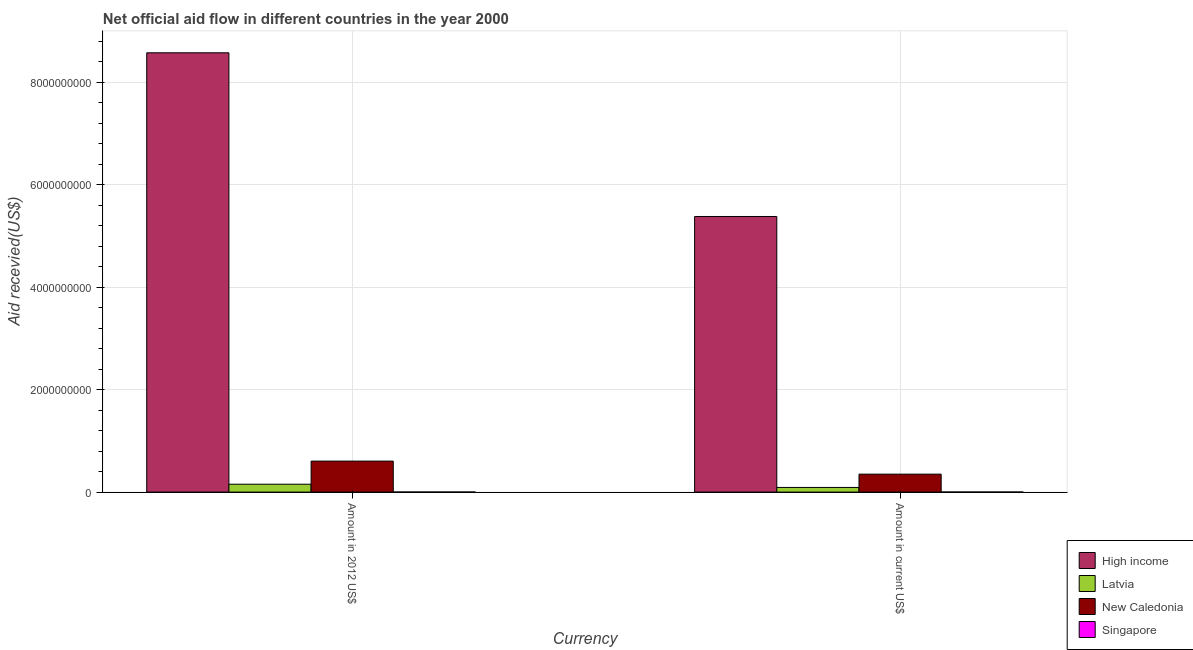How many different coloured bars are there?
Ensure brevity in your answer.  4. How many groups of bars are there?
Your answer should be very brief. 2. Are the number of bars per tick equal to the number of legend labels?
Provide a succinct answer. Yes. How many bars are there on the 1st tick from the left?
Your answer should be compact. 4. What is the label of the 2nd group of bars from the left?
Your answer should be very brief. Amount in current US$. What is the amount of aid received(expressed in us$) in High income?
Provide a short and direct response. 5.38e+09. Across all countries, what is the maximum amount of aid received(expressed in us$)?
Your response must be concise. 5.38e+09. Across all countries, what is the minimum amount of aid received(expressed in 2012 us$)?
Your answer should be very brief. 9.80e+05. In which country was the amount of aid received(expressed in us$) minimum?
Ensure brevity in your answer.  Singapore. What is the total amount of aid received(expressed in us$) in the graph?
Provide a short and direct response. 5.82e+09. What is the difference between the amount of aid received(expressed in us$) in New Caledonia and that in Singapore?
Your response must be concise. 3.49e+08. What is the difference between the amount of aid received(expressed in us$) in New Caledonia and the amount of aid received(expressed in 2012 us$) in High income?
Your response must be concise. -8.22e+09. What is the average amount of aid received(expressed in us$) per country?
Offer a very short reply. 1.46e+09. What is the difference between the amount of aid received(expressed in us$) and amount of aid received(expressed in 2012 us$) in Singapore?
Offer a terse response. 1.10e+05. What is the ratio of the amount of aid received(expressed in us$) in Singapore to that in New Caledonia?
Offer a very short reply. 0. Is the amount of aid received(expressed in 2012 us$) in New Caledonia less than that in Latvia?
Your response must be concise. No. What does the 4th bar from the left in Amount in current US$ represents?
Keep it short and to the point. Singapore. What does the 3rd bar from the right in Amount in 2012 US$ represents?
Provide a short and direct response. Latvia. How many bars are there?
Make the answer very short. 8. What is the difference between two consecutive major ticks on the Y-axis?
Your response must be concise. 2.00e+09. Does the graph contain grids?
Ensure brevity in your answer.  Yes. Where does the legend appear in the graph?
Make the answer very short. Bottom right. How many legend labels are there?
Offer a very short reply. 4. How are the legend labels stacked?
Make the answer very short. Vertical. What is the title of the graph?
Make the answer very short. Net official aid flow in different countries in the year 2000. What is the label or title of the X-axis?
Offer a very short reply. Currency. What is the label or title of the Y-axis?
Keep it short and to the point. Aid recevied(US$). What is the Aid recevied(US$) of High income in Amount in 2012 US$?
Provide a short and direct response. 8.57e+09. What is the Aid recevied(US$) of Latvia in Amount in 2012 US$?
Offer a very short reply. 1.54e+08. What is the Aid recevied(US$) in New Caledonia in Amount in 2012 US$?
Your answer should be compact. 6.05e+08. What is the Aid recevied(US$) in Singapore in Amount in 2012 US$?
Make the answer very short. 9.80e+05. What is the Aid recevied(US$) of High income in Amount in current US$?
Your answer should be very brief. 5.38e+09. What is the Aid recevied(US$) in Latvia in Amount in current US$?
Ensure brevity in your answer.  9.06e+07. What is the Aid recevied(US$) in New Caledonia in Amount in current US$?
Your response must be concise. 3.50e+08. What is the Aid recevied(US$) in Singapore in Amount in current US$?
Offer a very short reply. 1.09e+06. Across all Currency, what is the maximum Aid recevied(US$) of High income?
Offer a terse response. 8.57e+09. Across all Currency, what is the maximum Aid recevied(US$) of Latvia?
Ensure brevity in your answer.  1.54e+08. Across all Currency, what is the maximum Aid recevied(US$) in New Caledonia?
Your answer should be very brief. 6.05e+08. Across all Currency, what is the maximum Aid recevied(US$) in Singapore?
Your answer should be very brief. 1.09e+06. Across all Currency, what is the minimum Aid recevied(US$) in High income?
Offer a very short reply. 5.38e+09. Across all Currency, what is the minimum Aid recevied(US$) in Latvia?
Offer a very short reply. 9.06e+07. Across all Currency, what is the minimum Aid recevied(US$) of New Caledonia?
Offer a terse response. 3.50e+08. Across all Currency, what is the minimum Aid recevied(US$) in Singapore?
Offer a terse response. 9.80e+05. What is the total Aid recevied(US$) of High income in the graph?
Provide a succinct answer. 1.40e+1. What is the total Aid recevied(US$) in Latvia in the graph?
Offer a terse response. 2.44e+08. What is the total Aid recevied(US$) of New Caledonia in the graph?
Your answer should be very brief. 9.55e+08. What is the total Aid recevied(US$) in Singapore in the graph?
Provide a succinct answer. 2.07e+06. What is the difference between the Aid recevied(US$) of High income in Amount in 2012 US$ and that in Amount in current US$?
Ensure brevity in your answer.  3.19e+09. What is the difference between the Aid recevied(US$) of Latvia in Amount in 2012 US$ and that in Amount in current US$?
Your response must be concise. 6.32e+07. What is the difference between the Aid recevied(US$) in New Caledonia in Amount in 2012 US$ and that in Amount in current US$?
Your answer should be very brief. 2.55e+08. What is the difference between the Aid recevied(US$) of Singapore in Amount in 2012 US$ and that in Amount in current US$?
Offer a very short reply. -1.10e+05. What is the difference between the Aid recevied(US$) in High income in Amount in 2012 US$ and the Aid recevied(US$) in Latvia in Amount in current US$?
Give a very brief answer. 8.48e+09. What is the difference between the Aid recevied(US$) in High income in Amount in 2012 US$ and the Aid recevied(US$) in New Caledonia in Amount in current US$?
Your answer should be very brief. 8.22e+09. What is the difference between the Aid recevied(US$) in High income in Amount in 2012 US$ and the Aid recevied(US$) in Singapore in Amount in current US$?
Offer a very short reply. 8.57e+09. What is the difference between the Aid recevied(US$) in Latvia in Amount in 2012 US$ and the Aid recevied(US$) in New Caledonia in Amount in current US$?
Ensure brevity in your answer.  -1.96e+08. What is the difference between the Aid recevied(US$) of Latvia in Amount in 2012 US$ and the Aid recevied(US$) of Singapore in Amount in current US$?
Provide a short and direct response. 1.53e+08. What is the difference between the Aid recevied(US$) of New Caledonia in Amount in 2012 US$ and the Aid recevied(US$) of Singapore in Amount in current US$?
Offer a very short reply. 6.04e+08. What is the average Aid recevied(US$) of High income per Currency?
Provide a short and direct response. 6.98e+09. What is the average Aid recevied(US$) of Latvia per Currency?
Make the answer very short. 1.22e+08. What is the average Aid recevied(US$) in New Caledonia per Currency?
Provide a short and direct response. 4.77e+08. What is the average Aid recevied(US$) of Singapore per Currency?
Your response must be concise. 1.04e+06. What is the difference between the Aid recevied(US$) in High income and Aid recevied(US$) in Latvia in Amount in 2012 US$?
Your answer should be very brief. 8.42e+09. What is the difference between the Aid recevied(US$) in High income and Aid recevied(US$) in New Caledonia in Amount in 2012 US$?
Your answer should be compact. 7.97e+09. What is the difference between the Aid recevied(US$) in High income and Aid recevied(US$) in Singapore in Amount in 2012 US$?
Keep it short and to the point. 8.57e+09. What is the difference between the Aid recevied(US$) of Latvia and Aid recevied(US$) of New Caledonia in Amount in 2012 US$?
Provide a short and direct response. -4.51e+08. What is the difference between the Aid recevied(US$) in Latvia and Aid recevied(US$) in Singapore in Amount in 2012 US$?
Your answer should be very brief. 1.53e+08. What is the difference between the Aid recevied(US$) of New Caledonia and Aid recevied(US$) of Singapore in Amount in 2012 US$?
Give a very brief answer. 6.04e+08. What is the difference between the Aid recevied(US$) in High income and Aid recevied(US$) in Latvia in Amount in current US$?
Offer a very short reply. 5.29e+09. What is the difference between the Aid recevied(US$) of High income and Aid recevied(US$) of New Caledonia in Amount in current US$?
Give a very brief answer. 5.03e+09. What is the difference between the Aid recevied(US$) in High income and Aid recevied(US$) in Singapore in Amount in current US$?
Provide a succinct answer. 5.38e+09. What is the difference between the Aid recevied(US$) in Latvia and Aid recevied(US$) in New Caledonia in Amount in current US$?
Your answer should be very brief. -2.60e+08. What is the difference between the Aid recevied(US$) in Latvia and Aid recevied(US$) in Singapore in Amount in current US$?
Offer a terse response. 8.95e+07. What is the difference between the Aid recevied(US$) of New Caledonia and Aid recevied(US$) of Singapore in Amount in current US$?
Make the answer very short. 3.49e+08. What is the ratio of the Aid recevied(US$) in High income in Amount in 2012 US$ to that in Amount in current US$?
Make the answer very short. 1.59. What is the ratio of the Aid recevied(US$) of Latvia in Amount in 2012 US$ to that in Amount in current US$?
Your answer should be very brief. 1.7. What is the ratio of the Aid recevied(US$) in New Caledonia in Amount in 2012 US$ to that in Amount in current US$?
Your answer should be very brief. 1.73. What is the ratio of the Aid recevied(US$) in Singapore in Amount in 2012 US$ to that in Amount in current US$?
Give a very brief answer. 0.9. What is the difference between the highest and the second highest Aid recevied(US$) of High income?
Keep it short and to the point. 3.19e+09. What is the difference between the highest and the second highest Aid recevied(US$) of Latvia?
Offer a terse response. 6.32e+07. What is the difference between the highest and the second highest Aid recevied(US$) in New Caledonia?
Your answer should be compact. 2.55e+08. What is the difference between the highest and the lowest Aid recevied(US$) in High income?
Provide a short and direct response. 3.19e+09. What is the difference between the highest and the lowest Aid recevied(US$) in Latvia?
Offer a very short reply. 6.32e+07. What is the difference between the highest and the lowest Aid recevied(US$) of New Caledonia?
Your response must be concise. 2.55e+08. 